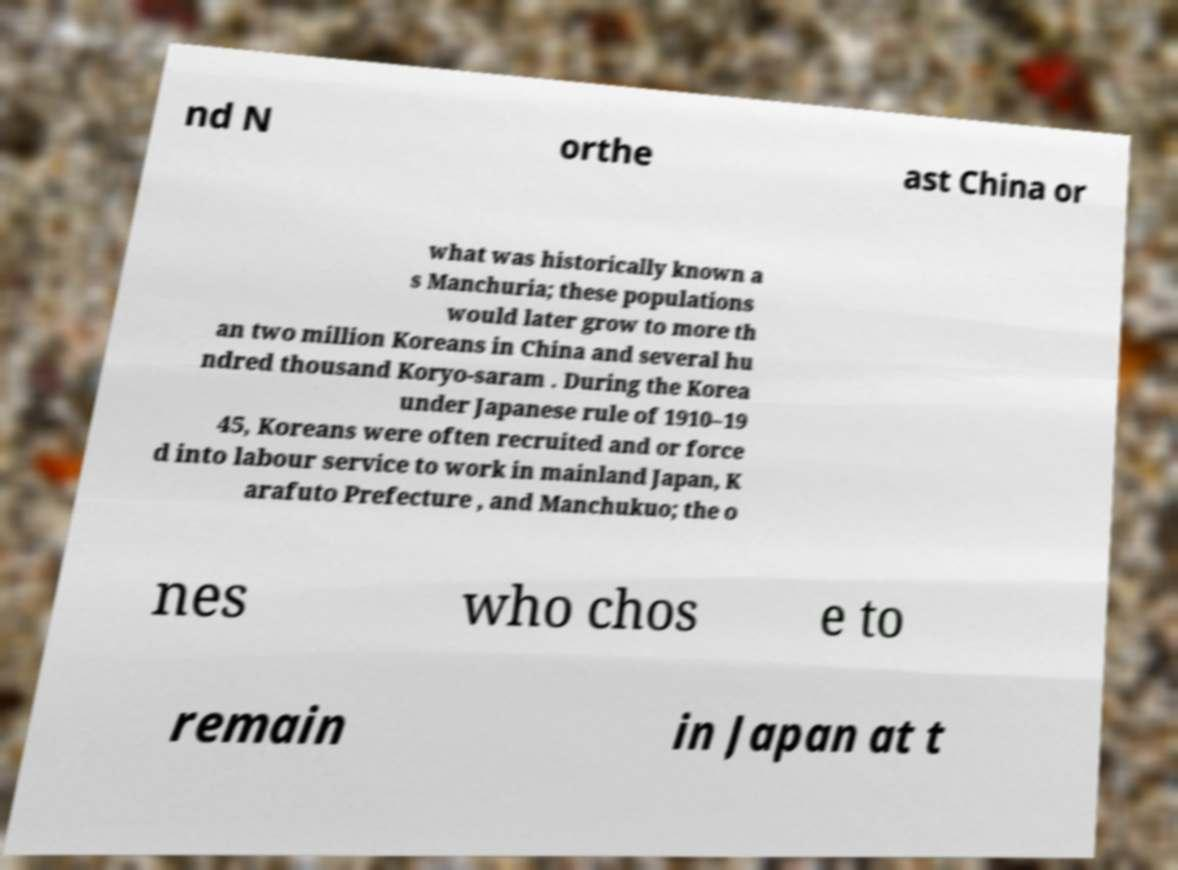There's text embedded in this image that I need extracted. Can you transcribe it verbatim? nd N orthe ast China or what was historically known a s Manchuria; these populations would later grow to more th an two million Koreans in China and several hu ndred thousand Koryo-saram . During the Korea under Japanese rule of 1910–19 45, Koreans were often recruited and or force d into labour service to work in mainland Japan, K arafuto Prefecture , and Manchukuo; the o nes who chos e to remain in Japan at t 